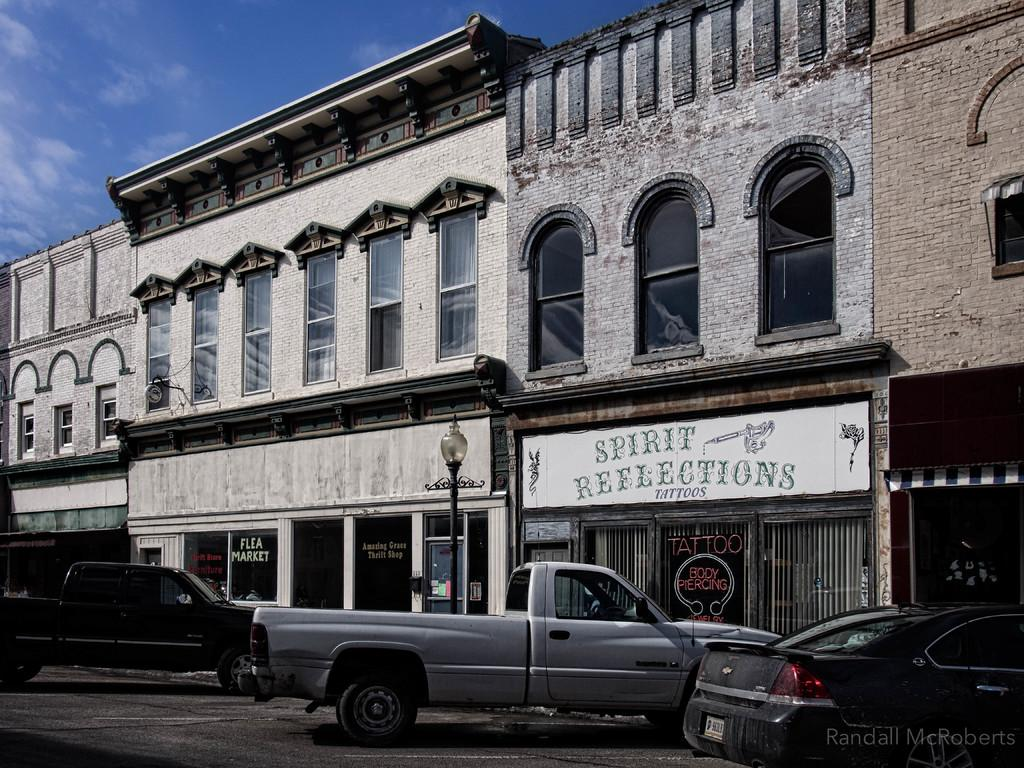What type of structure is visible in the image? There is a building in the image. What vehicles can be seen parked in the image? A car and mini trucks are parked in the image. What type of lighting is present in the image? There is a pole light in the image. Is there any text or marking in the image? Yes, there is a watermark in the bottom right corner of the image. How would you describe the sky in the image? The sky is blue and cloudy in the image. What type of spoon is used to stir the hope in the image? There is no spoon or hope present in the image; it features a building, vehicles, a pole light, a watermark, and a blue and cloudy sky. What type of frame surrounds the image? The question about the frame is irrelevant, as we are discussing the contents of the image itself and not the physical representation of the image. 